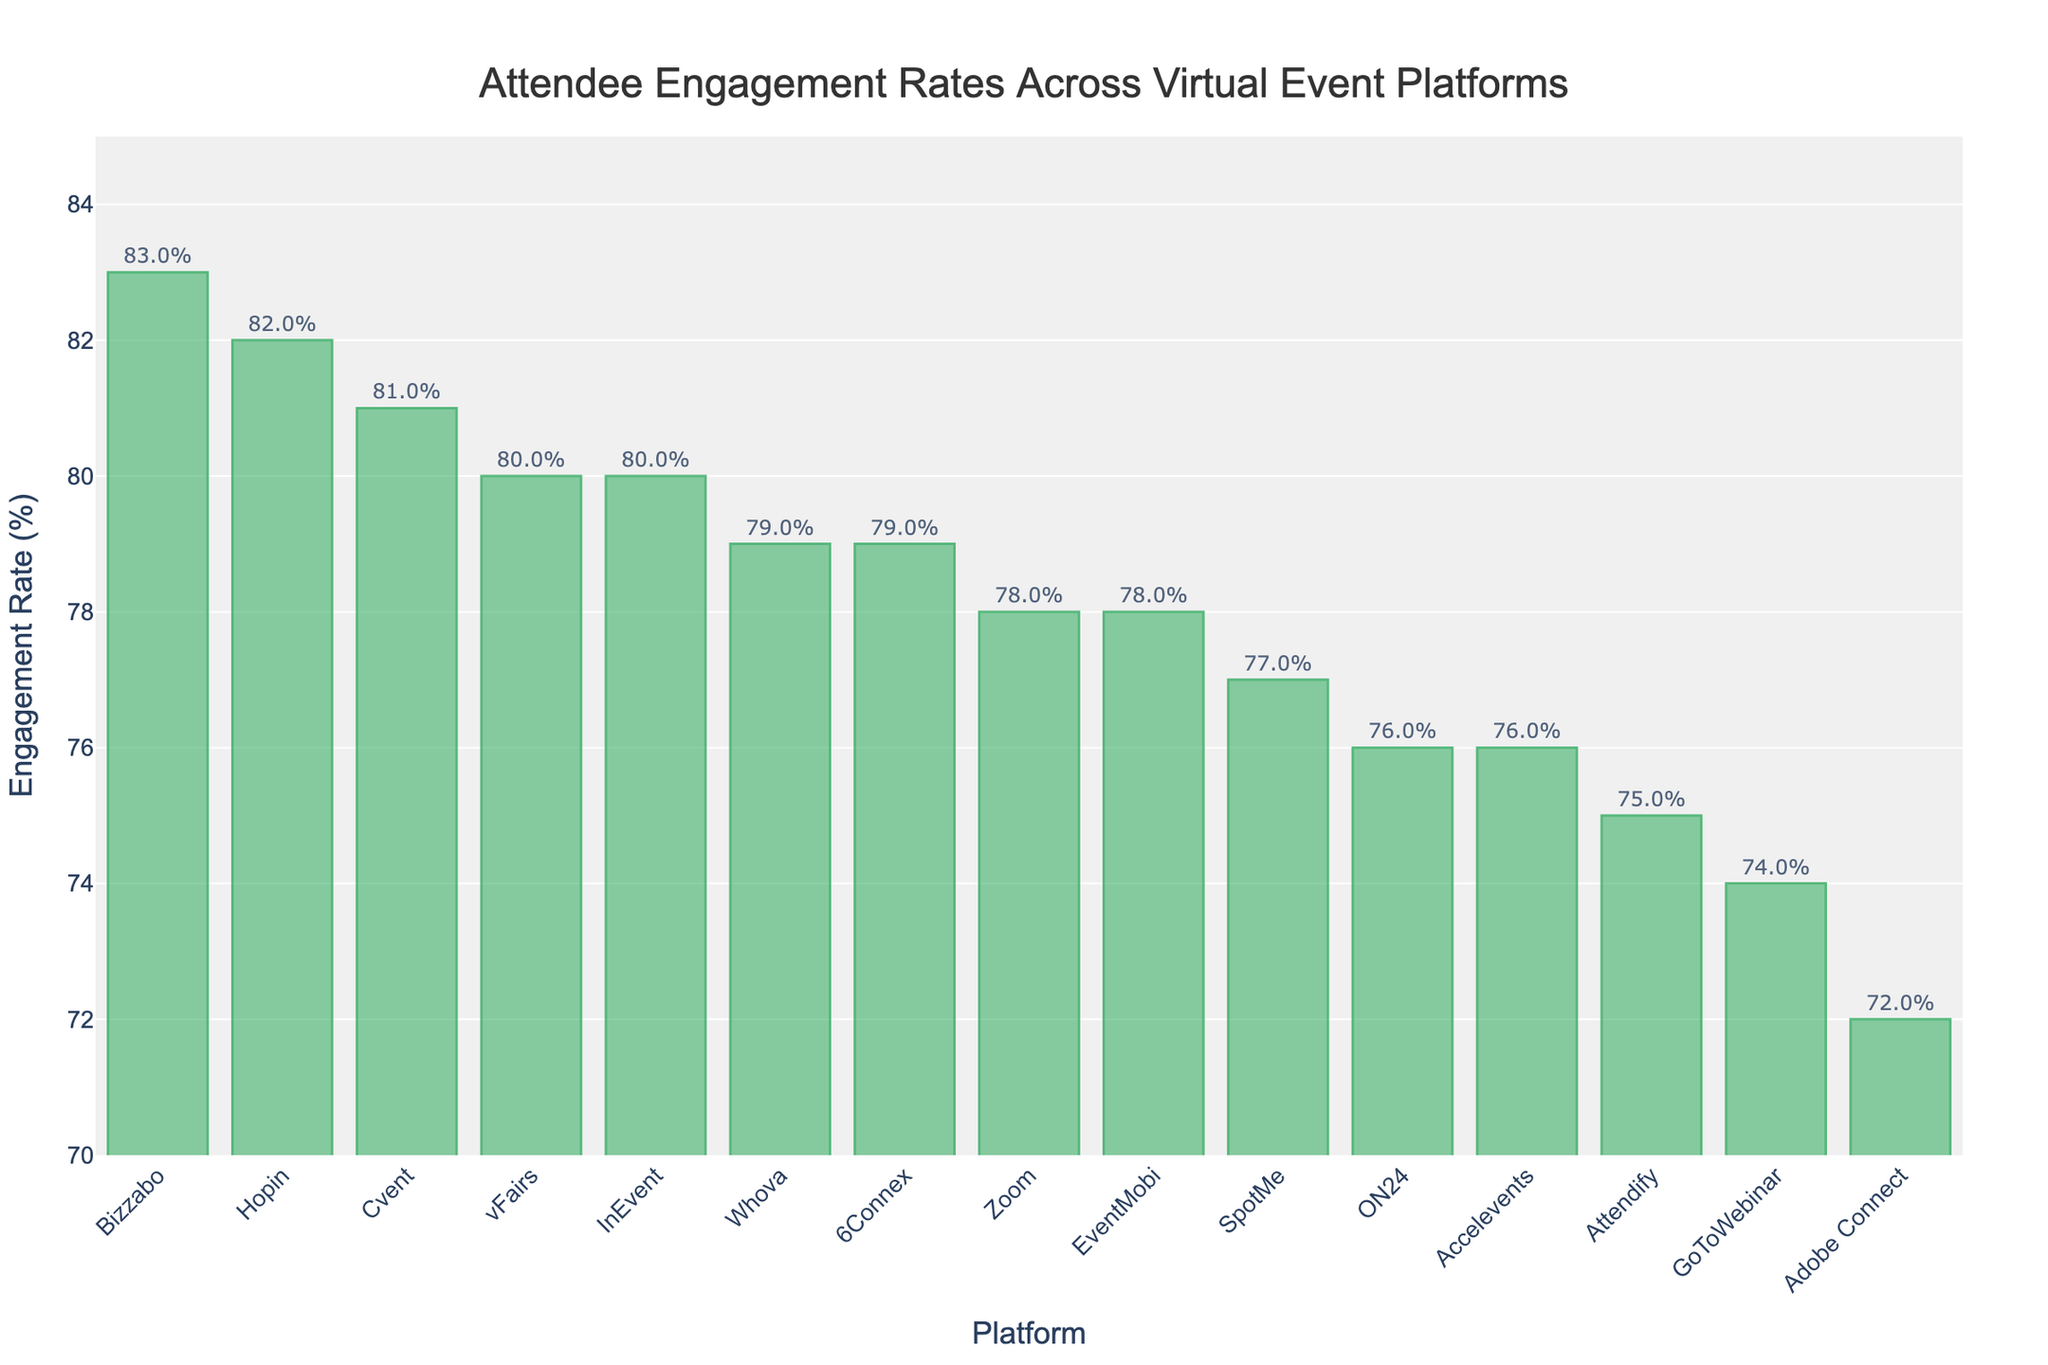Which platform has the highest engagement rate? The platform with the highest engagement rate is found by looking for the bar that reaches the highest point on the y-axis.
Answer: Bizzabo Which two platforms have engagement rates that are equal? By examining the heights of the bars carefully, we see that both Whova and 6Connex have engagement rates of 79%.
Answer: Whova and 6Connex What's the average engagement rate of the top three platforms? The top three platforms by engagement rate are Bizzabo (83%), Hopin (82%), and Cvent (81%). The average is calculated as (83 + 82 + 81) / 3 = 82.
Answer: 82 Which platform has a lower engagement rate, ON24 or SpotMe? Comparing the heights of the bars for ON24 (76%) and SpotMe (77%), ON24 is lower.
Answer: ON24 What’s the difference in engagement rate between the platform with the highest rate and the platform with the lowest rate? The highest rate is 83% (Bizzabo) and the lowest is 72% (Adobe Connect). The difference is 83 - 72 = 11.
Answer: 11 Are there more platforms with an engagement rate above 80% or below 75%? Count the platforms with an engagement rate above 80%: Hopin, Bizzabo, Cvent, (3). Count the platforms below 75%: GoToWebinar (74%), Adobe Connect (72%), (2).
Answer: Above 80% Which platform's engagement rate is closest to the median engagement rate of all platforms? Arrange the rates in order: 72, 74, 75, 76, 76, 77, 78, 78, 79, 79, 80, 80, 81, 82, 83. The median (middle value) is 78, with platforms Zoom and EventMobi both showing this rate.
Answer: Zoom and EventMobi What is the total engagement rate for all platforms combined? Sum all rates: 78 + 82 + 75 + 80 + 76 + 79 + 83 + 77 + 74 + 81 + 72 + 78 + 76 + 79 + 80 = 1190.
Answer: 1190 By how many percentage points does the engagement rate of Cvent exceed ON24? Cvent has 81% and ON24 has 76%, so the difference is 81 - 76 = 5.
Answer: 5 Which platforms have engagement rates within 2 percentage points of 80%? Identify platforms with rates between 78% and 82%. Those are: Zoom (78), Hopin (82), vFairs (80), Cvent (81), Whova (79), Bizzabo (83), EventMobi (78), InEvent (80).
Answer: Zoom, Hopin, vFairs, Cvent, Whova, Bizzabo, EventMobi, InEvent 